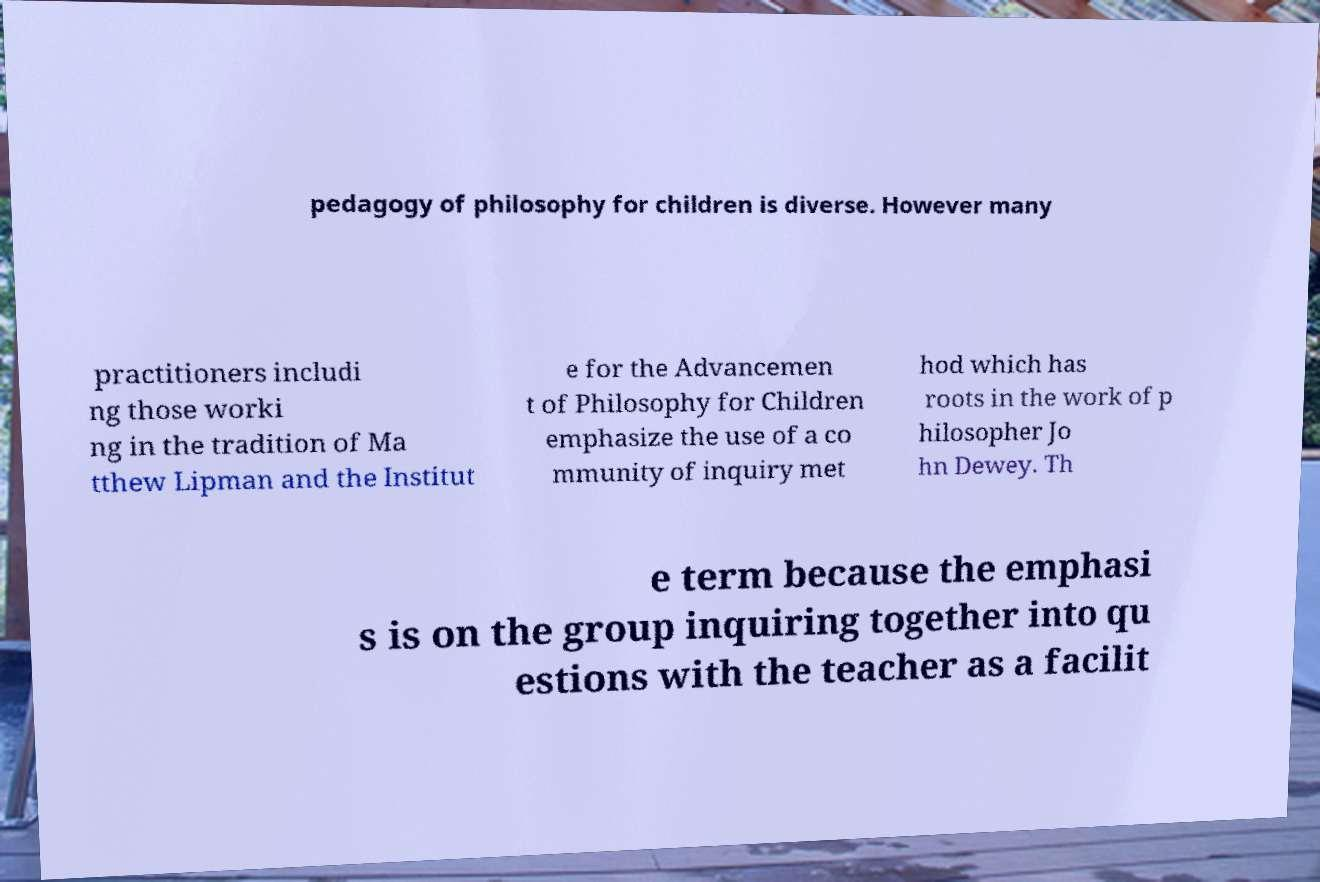Can you read and provide the text displayed in the image?This photo seems to have some interesting text. Can you extract and type it out for me? pedagogy of philosophy for children is diverse. However many practitioners includi ng those worki ng in the tradition of Ma tthew Lipman and the Institut e for the Advancemen t of Philosophy for Children emphasize the use of a co mmunity of inquiry met hod which has roots in the work of p hilosopher Jo hn Dewey. Th e term because the emphasi s is on the group inquiring together into qu estions with the teacher as a facilit 